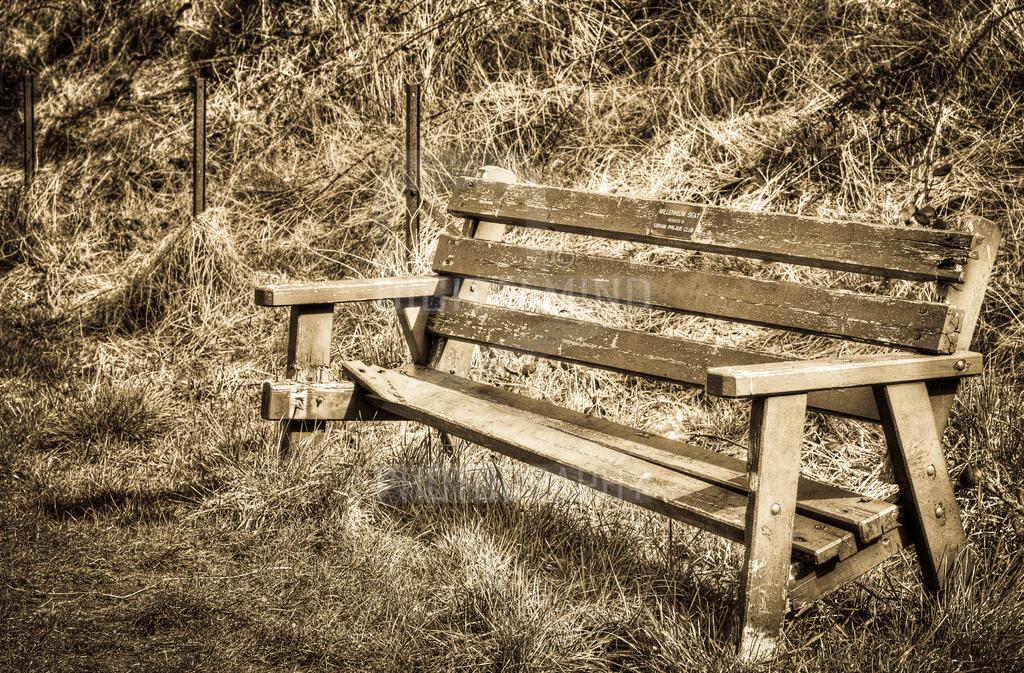What type of vegetation is present in the image? There is dry grass in the image. What type of seating is visible in the image? There is a bench in the image. What type of flag is flying over the industry in the image? There is no flag or industry present in the image; it only features dry grass and a bench. What type of meal is being prepared on the bench in the image? There is no meal being prepared or served on the bench in the image; it is a seating structure. 